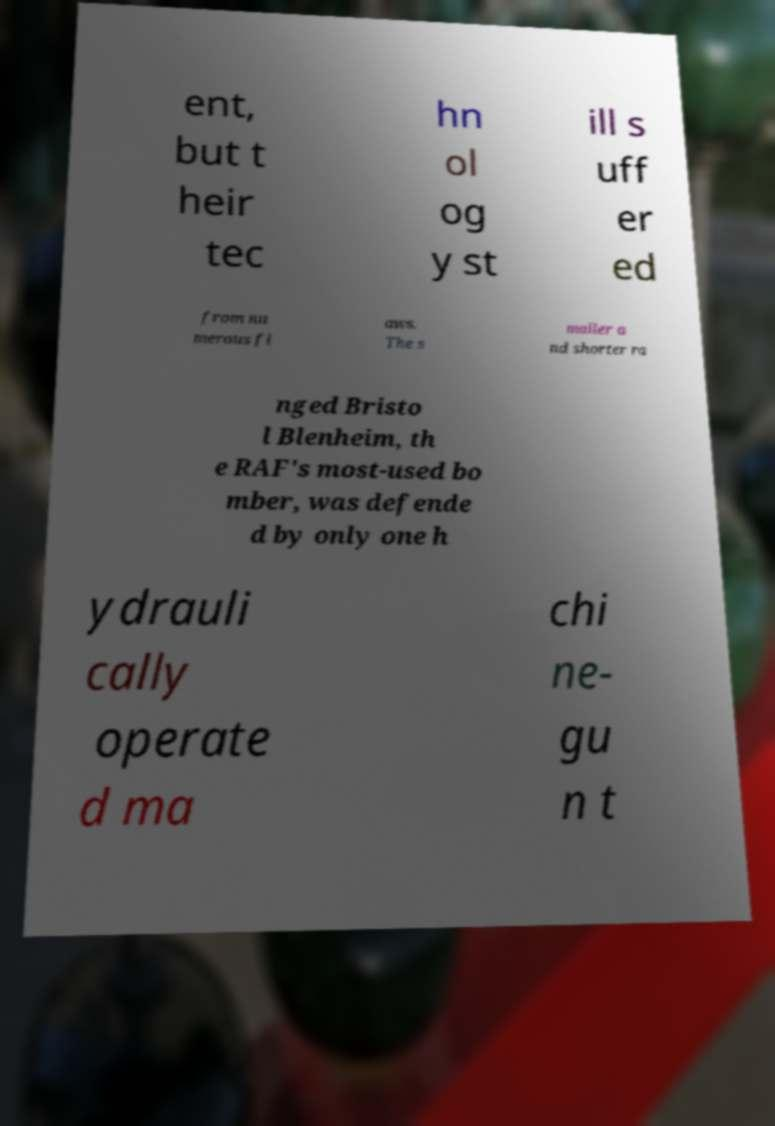There's text embedded in this image that I need extracted. Can you transcribe it verbatim? ent, but t heir tec hn ol og y st ill s uff er ed from nu merous fl aws. The s maller a nd shorter ra nged Bristo l Blenheim, th e RAF's most-used bo mber, was defende d by only one h ydrauli cally operate d ma chi ne- gu n t 